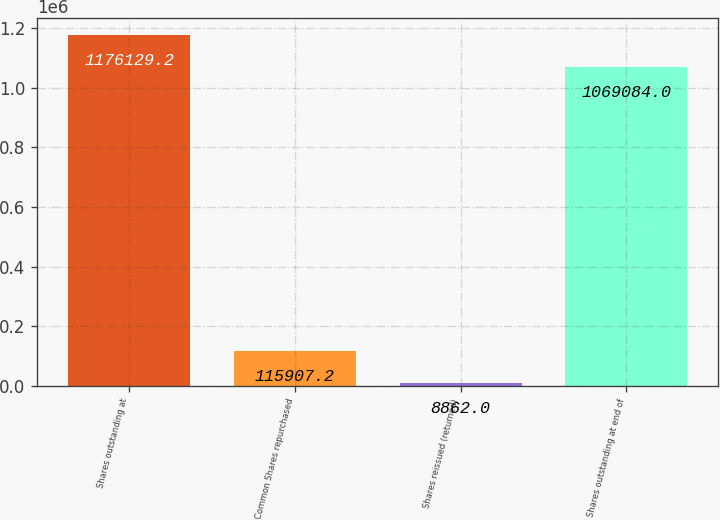Convert chart to OTSL. <chart><loc_0><loc_0><loc_500><loc_500><bar_chart><fcel>Shares outstanding at<fcel>Common Shares repurchased<fcel>Shares reissued (returned)<fcel>Shares outstanding at end of<nl><fcel>1.17613e+06<fcel>115907<fcel>8862<fcel>1.06908e+06<nl></chart> 